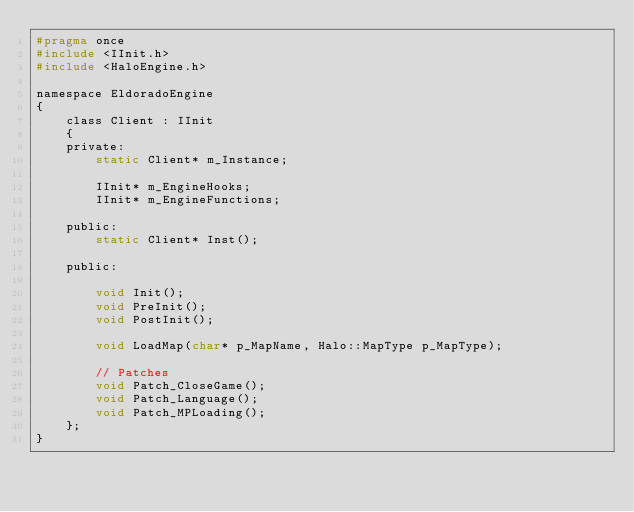<code> <loc_0><loc_0><loc_500><loc_500><_C_>#pragma once
#include <IInit.h>
#include <HaloEngine.h>

namespace EldoradoEngine
{
	class Client : IInit
	{
	private:
		static Client* m_Instance;

		IInit* m_EngineHooks;
		IInit* m_EngineFunctions;

	public:
		static Client* Inst();

	public:

		void Init();
		void PreInit();
		void PostInit();

		void LoadMap(char* p_MapName, Halo::MapType p_MapType);

		// Patches
		void Patch_CloseGame();
		void Patch_Language();
		void Patch_MPLoading();
	};
}</code> 